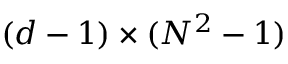<formula> <loc_0><loc_0><loc_500><loc_500>( d - 1 ) \times ( N ^ { 2 } - 1 )</formula> 